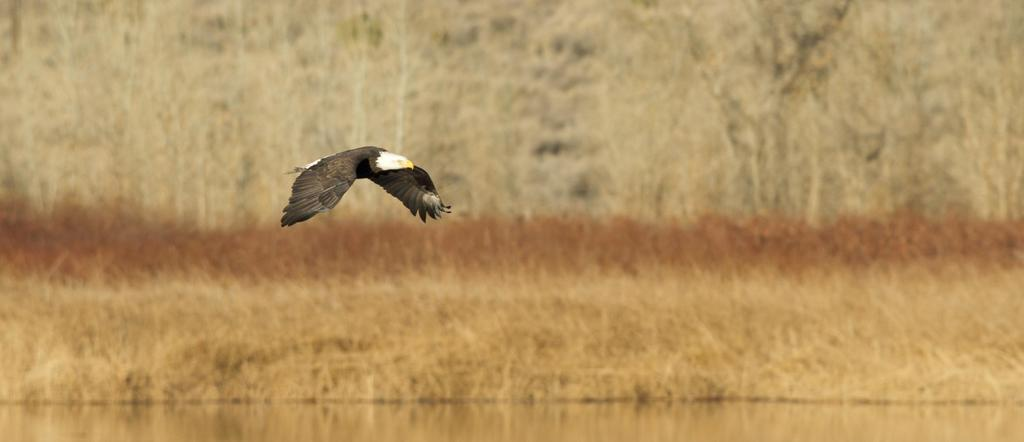What animal is featured in the image? There is an eagle in the image. What is the eagle doing in the image? The eagle is flying in the air. Can you describe the coloring of the eagle? The eagle has white and brown coloring. What natural element can be seen in the image? There is water visible in the image. What type of vegetation is present in the background of the image? There is dried grass in the background of the image. What else can be seen in the background of the image? There are trees in the background of the image. What type of texture can be seen on the station in the image? There is no station present in the image; it features an eagle flying in the air. 